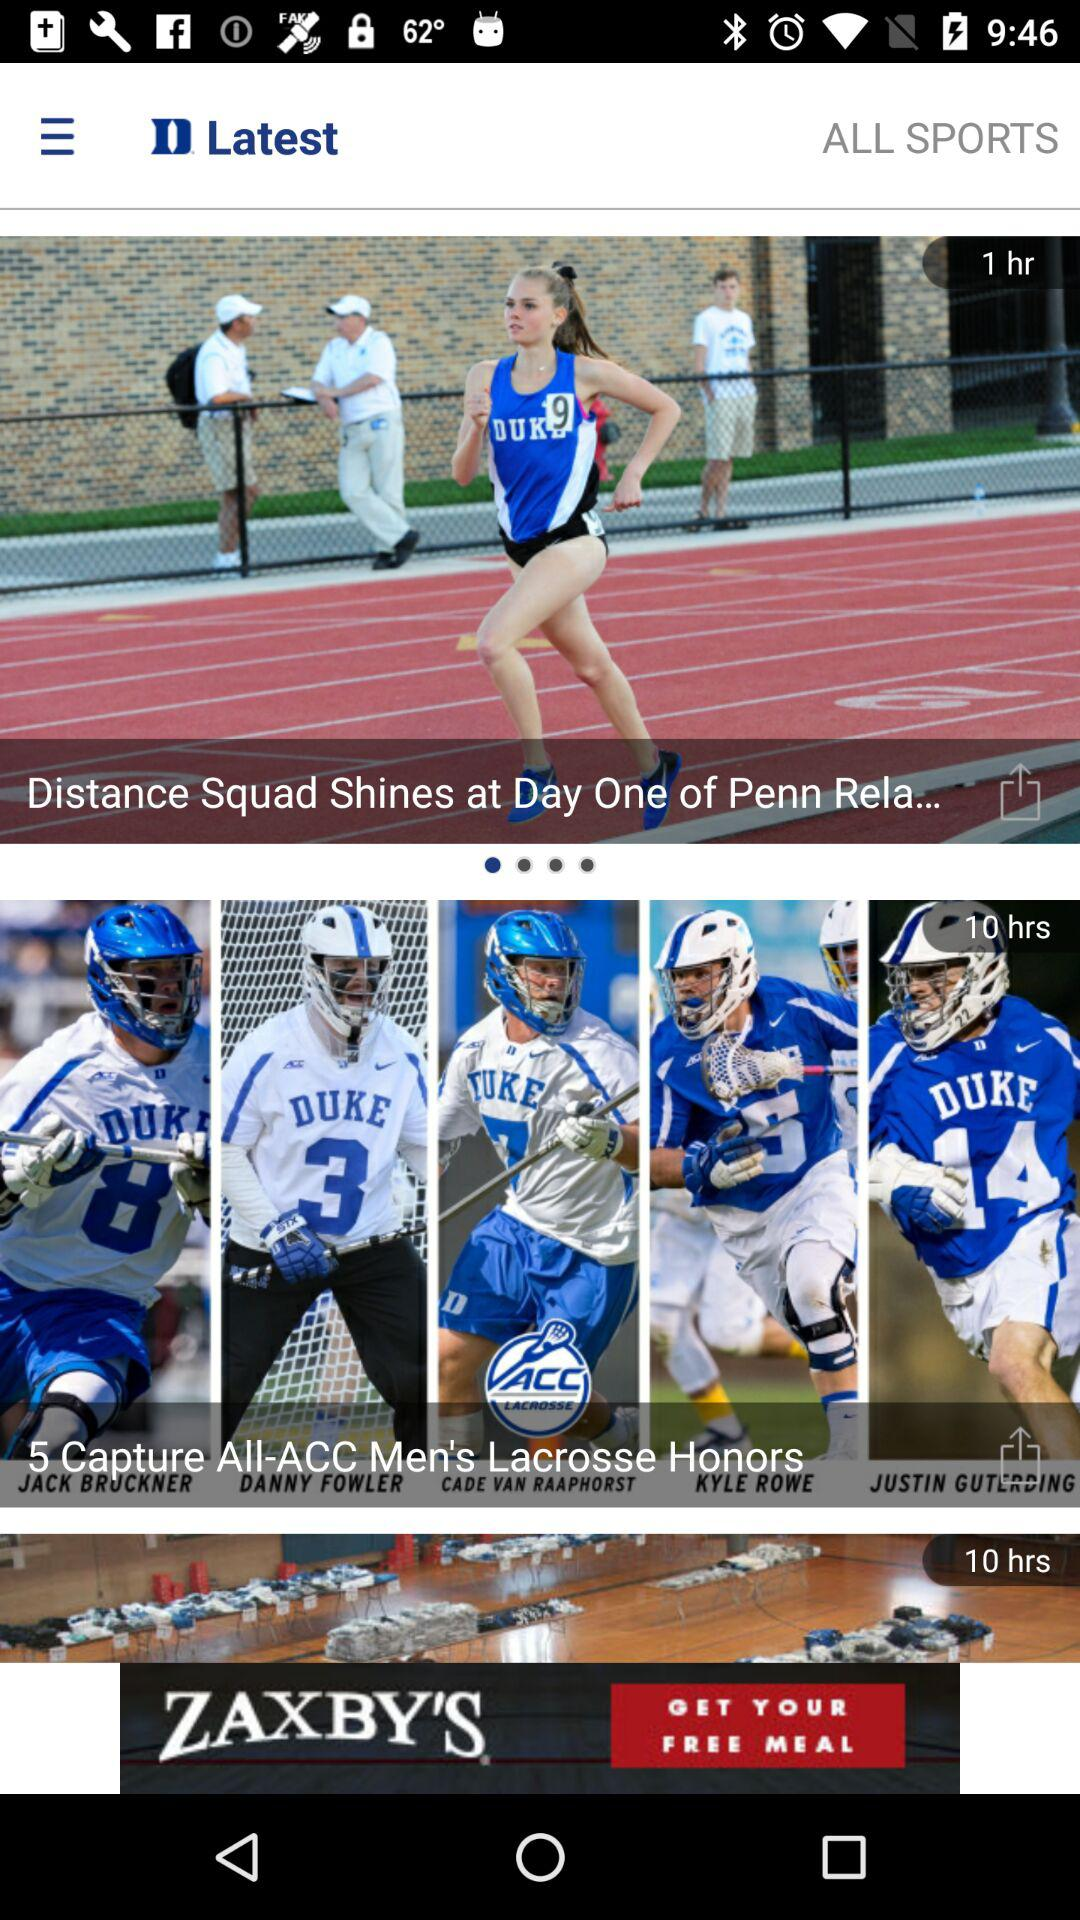How many more hours ago was the article about Justin Guting than the article about the Distance Squad?
Answer the question using a single word or phrase. 9 